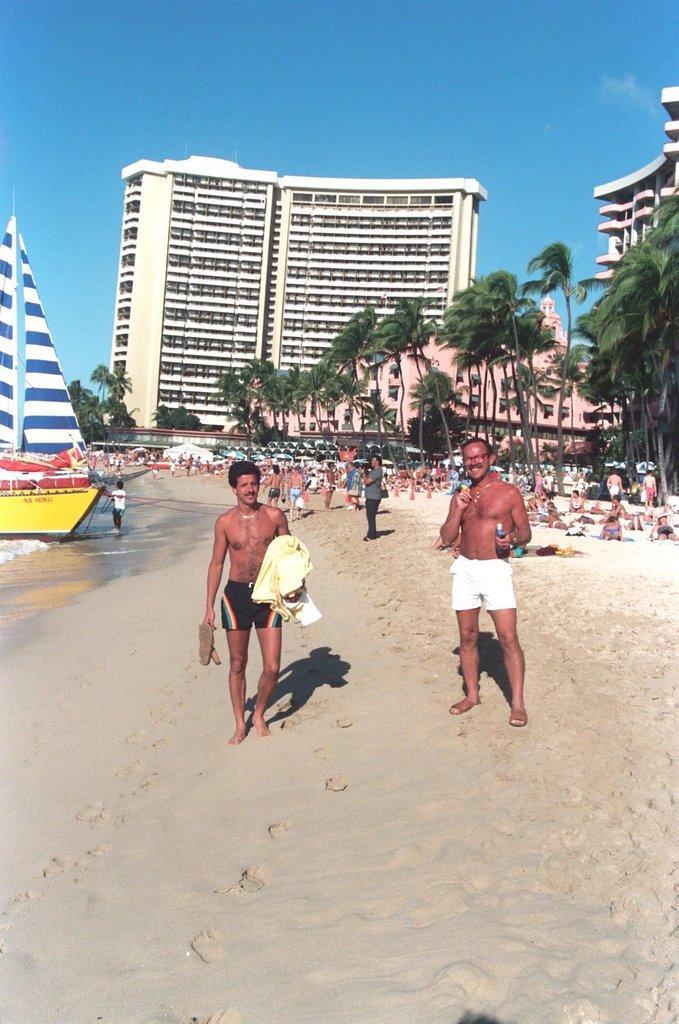How would you summarize this image in a sentence or two? There are people walking on the sand, there are trees, people, a ship, buildings and the sky in the background. 